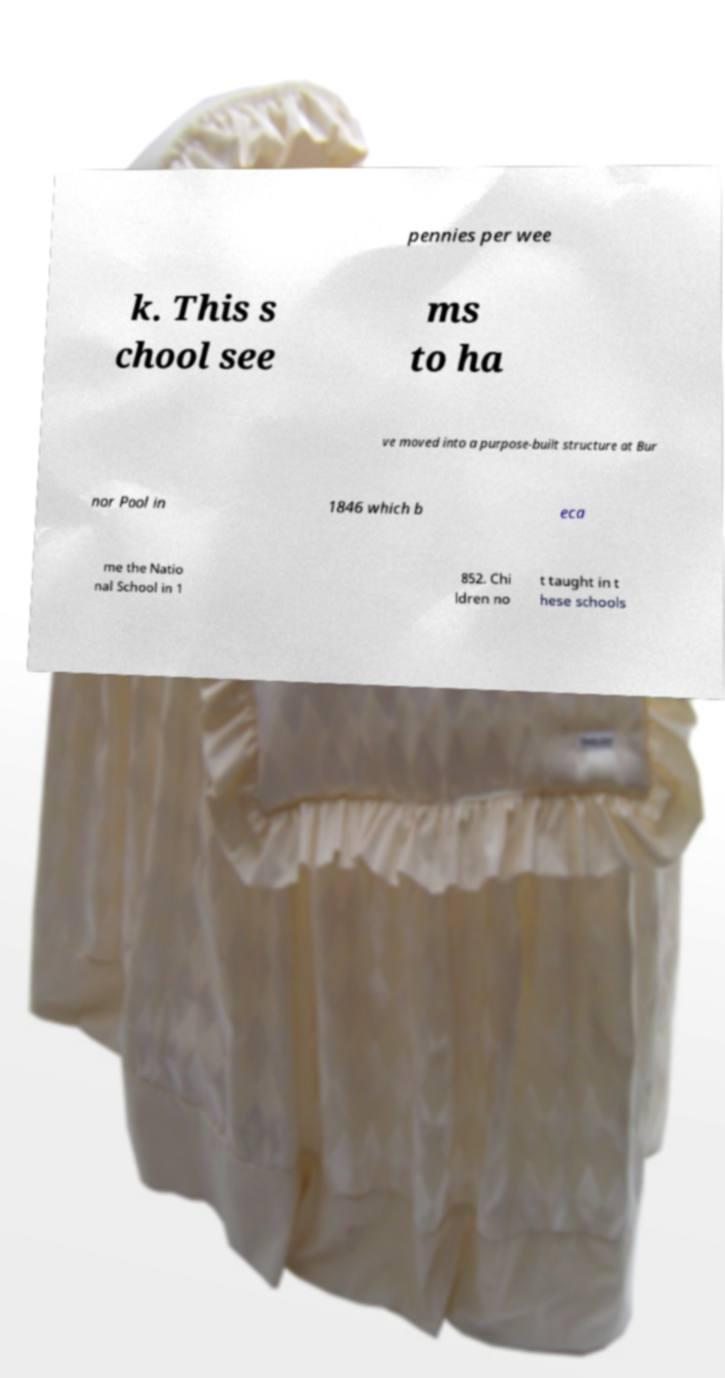Can you read and provide the text displayed in the image?This photo seems to have some interesting text. Can you extract and type it out for me? pennies per wee k. This s chool see ms to ha ve moved into a purpose-built structure at Bur nor Pool in 1846 which b eca me the Natio nal School in 1 852. Chi ldren no t taught in t hese schools 